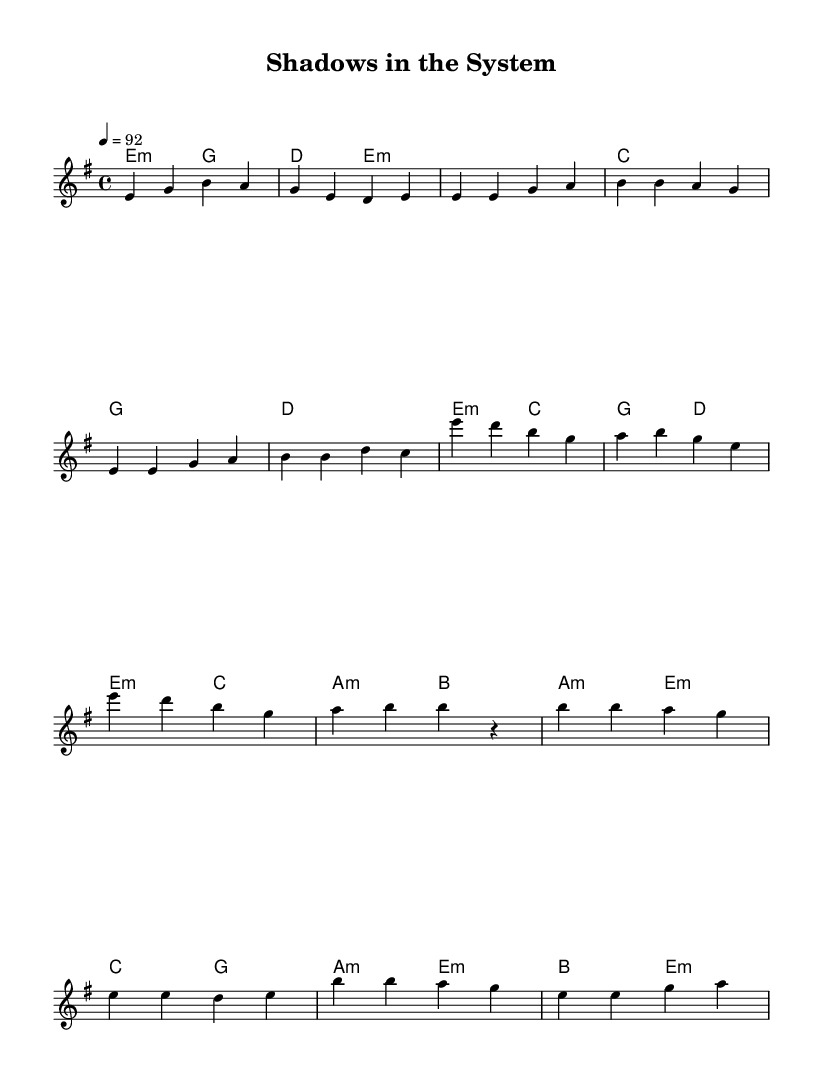What is the key signature of this music? The key signature indicates E minor, which has one sharp (F#). It can be determined by looking at the key signature notated at the beginning of the score.
Answer: E minor What is the time signature of this music? The time signature is 4/4, which means there are four beats in each measure. This is given at the beginning of the score.
Answer: 4/4 What is the tempo indicated in the piece? The tempo is marked as 92 beats per minute, as shown at the start of the score under the tempo indication.
Answer: 92 How many measures are there in the Chorus section? The chorus consists of two measures, which can be counted from the notation within the score. It is clearly outlined in a separate section under the "Chorus" label.
Answer: 2 What is the first note of the Bridge? The first note of the Bridge is B, as can be seen in the melody line under the "Bridge" section.
Answer: B Describe the harmony progression in the Chorus. The harmony progression in the chorus follows E minor, C, G, D, and concludes with E minor, C, A minor, B. This sequence can be traced through the chord names provided in the harmonies section.
Answer: E minor, C, G, D Which note appears most frequently in the first verse? The note E appears most frequently in the first verse, as observed by counting its occurrences in the melody line spanning the measures.
Answer: E 